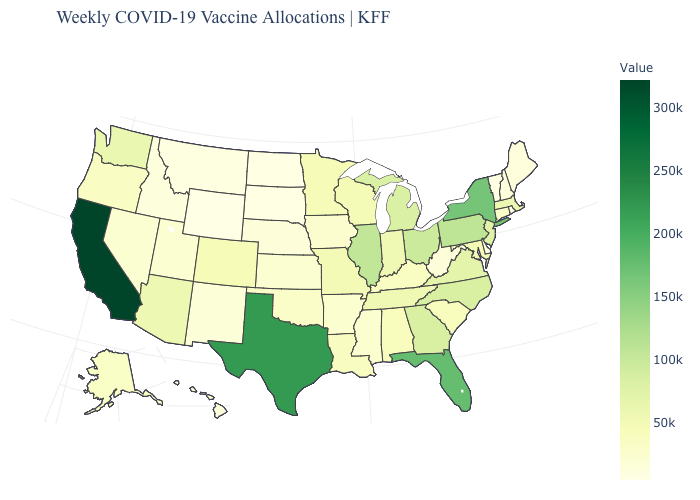Among the states that border Oregon , does California have the highest value?
Concise answer only. Yes. Which states have the lowest value in the USA?
Short answer required. Wyoming. Among the states that border North Dakota , which have the highest value?
Concise answer only. Minnesota. Does Missouri have a higher value than Ohio?
Keep it brief. No. Among the states that border Oregon , does Idaho have the lowest value?
Write a very short answer. Yes. Among the states that border North Carolina , which have the highest value?
Short answer required. Georgia. 